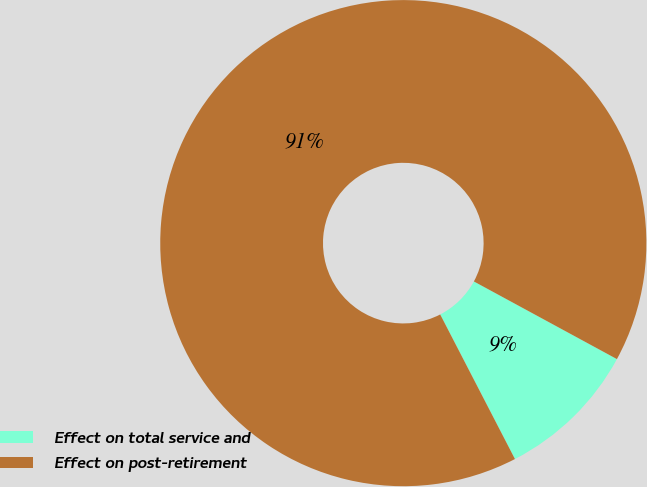Convert chart to OTSL. <chart><loc_0><loc_0><loc_500><loc_500><pie_chart><fcel>Effect on total service and<fcel>Effect on post-retirement<nl><fcel>9.49%<fcel>90.51%<nl></chart> 